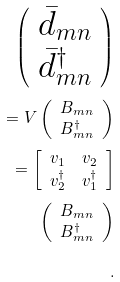Convert formula to latex. <formula><loc_0><loc_0><loc_500><loc_500>\left ( \begin{array} { c } \bar { d } _ { m n } \\ \bar { d } _ { m n } ^ { \dagger } \\ \end{array} \right ) \\ = V \left ( \begin{array} { c } B _ { m n } \\ B _ { m n } ^ { \dagger } \\ \end{array} \right ) \\ = \left [ \begin{array} { c c } v _ { 1 } & v _ { 2 } \\ v _ { 2 } ^ { \dagger } & v _ { 1 } ^ { \dagger } \\ \end{array} \right ] \\ \left ( \begin{array} { c } B _ { m n } \\ B _ { m n } ^ { \dagger } \\ \end{array} \right ) \\ .</formula> 